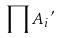<formula> <loc_0><loc_0><loc_500><loc_500>\prod { A _ { i } } ^ { \prime }</formula> 